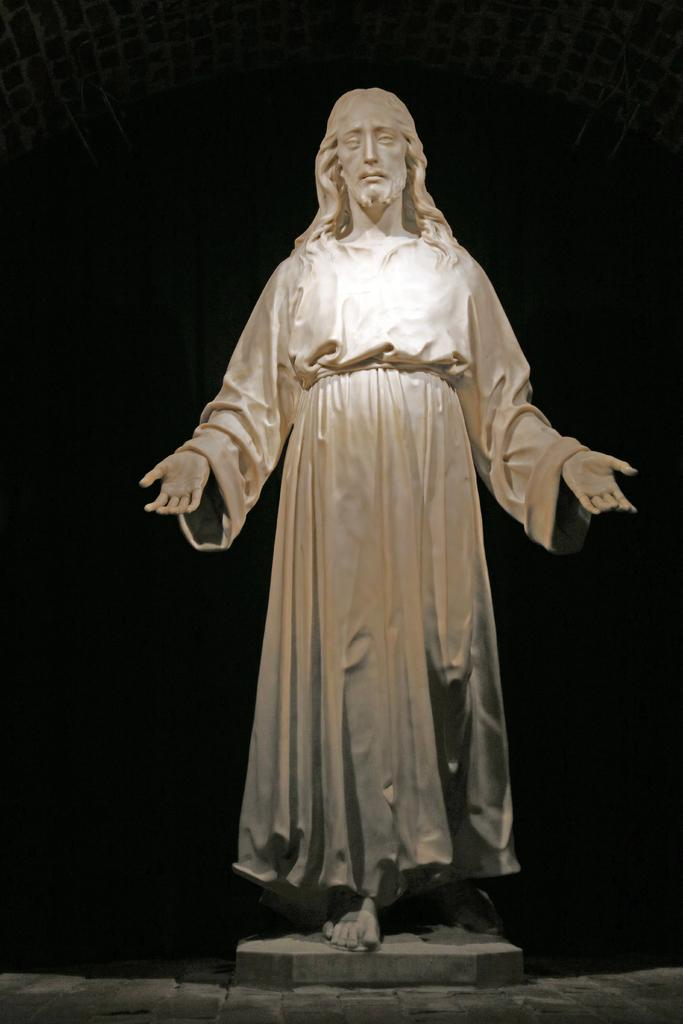What is the main subject of the image? There is a statue in the image. What is the statue of? The statue is of a person. What position is the person depicted in the statue? The person depicted in the statue is standing. What type of wrench is the person holding in the statue? There is no wrench present in the image, as the statue is of a person who is not holding any tools. 